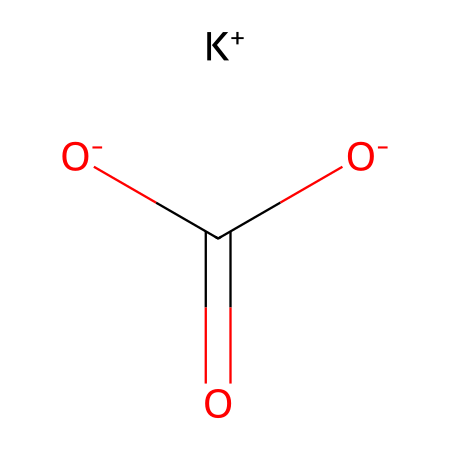What is the chemical formula of potassium bicarbonate? The SMILES representation shows the presence of potassium (K), carbon (C), oxygen (O), and hydrogen (H). From the structure, we can deduce that the formula is KHC₃O₃, which indicates potassium bicarbonate.
Answer: KHC₃O₃ How many oxygen atoms are present in potassium bicarbonate? In the SMILES, we can see three instances of the oxygen atom represented as O and O- in the structure, including two oxygen atoms in the carboxylate group (-COO) and one in the bicarbonate. Therefore, there are three oxygen atoms.
Answer: three Is potassium bicarbonate an acid, base, or neutral? Given the presence of bicarbonate (HCO₃-) in the chemical structure, which acts as a weak acid, and the potassium ion (K+), which does not donate protons, potassium bicarbonate is considered a weak base.
Answer: weak base What type of compound is potassium bicarbonate? The structure exhibits characteristics of a salt due to the ionic bond between potassium ions (K+) and bicarbonate ions (HCO₃-). Thus, it is classified as an inorganic salt.
Answer: inorganic salt What role does potassium bicarbonate play as an electrolyte? Potassium bicarbonate dissociates into potassium ions (K+) and bicarbonate ions (HCO₃-) when dissolved in water, which are essential for conducting electricity in solutions, making it an effective electrolyte.
Answer: conducting electricity How many total atoms are present in potassium bicarbonate? To find the total, we count the respective atoms: 1 potassium (K), 1 carbon (C), 3 oxygens (O), and 1 hydrogen (H), which totals to 6 atoms.
Answer: six 